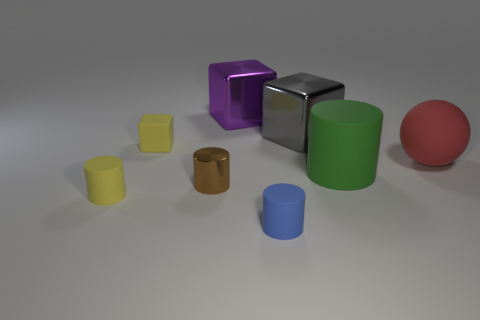Is there a brown metal thing on the left side of the object that is left of the small yellow matte object behind the metal cylinder?
Provide a short and direct response. No. What is the size of the matte cylinder to the left of the rubber block?
Provide a short and direct response. Small. What is the material of the purple cube that is the same size as the green object?
Offer a terse response. Metal. Does the tiny brown shiny object have the same shape as the big purple object?
Offer a terse response. No. How many objects are either big matte balls or matte things in front of the big red rubber ball?
Ensure brevity in your answer.  4. There is a object that is the same color as the matte cube; what material is it?
Make the answer very short. Rubber. Is the size of the matte cylinder left of the matte block the same as the blue thing?
Offer a terse response. Yes. What number of rubber cylinders are to the left of the metallic object that is to the right of the tiny matte cylinder that is to the right of the tiny metallic cylinder?
Provide a succinct answer. 2. How many yellow things are either big matte things or matte balls?
Provide a succinct answer. 0. What is the color of the big sphere that is made of the same material as the large cylinder?
Make the answer very short. Red. 